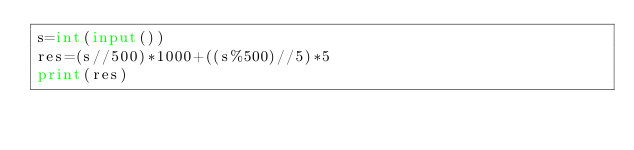<code> <loc_0><loc_0><loc_500><loc_500><_Python_>s=int(input())
res=(s//500)*1000+((s%500)//5)*5
print(res)</code> 